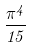<formula> <loc_0><loc_0><loc_500><loc_500>\frac { \pi ^ { 4 } } { 1 5 }</formula> 